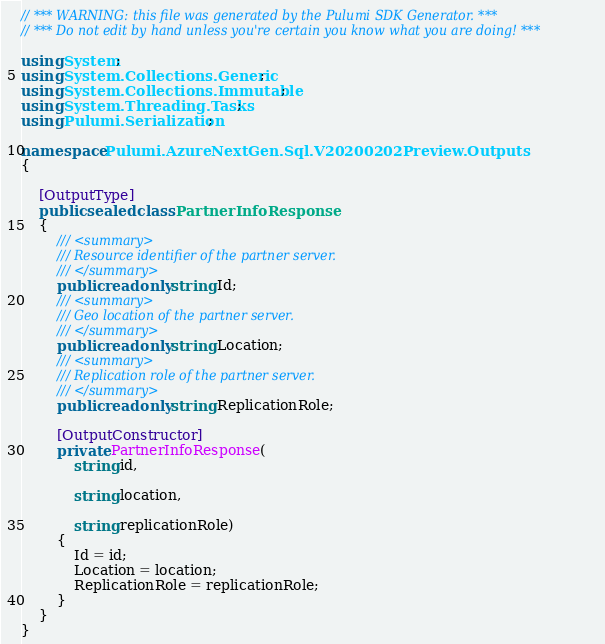Convert code to text. <code><loc_0><loc_0><loc_500><loc_500><_C#_>// *** WARNING: this file was generated by the Pulumi SDK Generator. ***
// *** Do not edit by hand unless you're certain you know what you are doing! ***

using System;
using System.Collections.Generic;
using System.Collections.Immutable;
using System.Threading.Tasks;
using Pulumi.Serialization;

namespace Pulumi.AzureNextGen.Sql.V20200202Preview.Outputs
{

    [OutputType]
    public sealed class PartnerInfoResponse
    {
        /// <summary>
        /// Resource identifier of the partner server.
        /// </summary>
        public readonly string Id;
        /// <summary>
        /// Geo location of the partner server.
        /// </summary>
        public readonly string Location;
        /// <summary>
        /// Replication role of the partner server.
        /// </summary>
        public readonly string ReplicationRole;

        [OutputConstructor]
        private PartnerInfoResponse(
            string id,

            string location,

            string replicationRole)
        {
            Id = id;
            Location = location;
            ReplicationRole = replicationRole;
        }
    }
}
</code> 